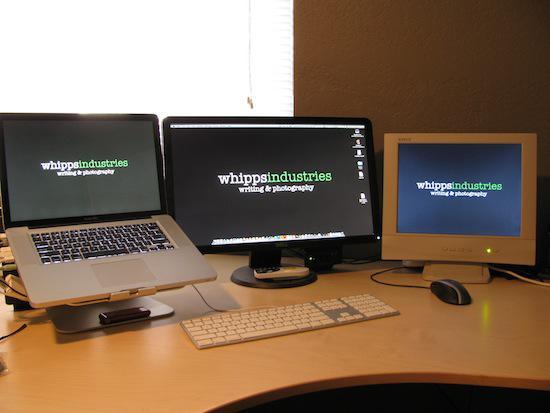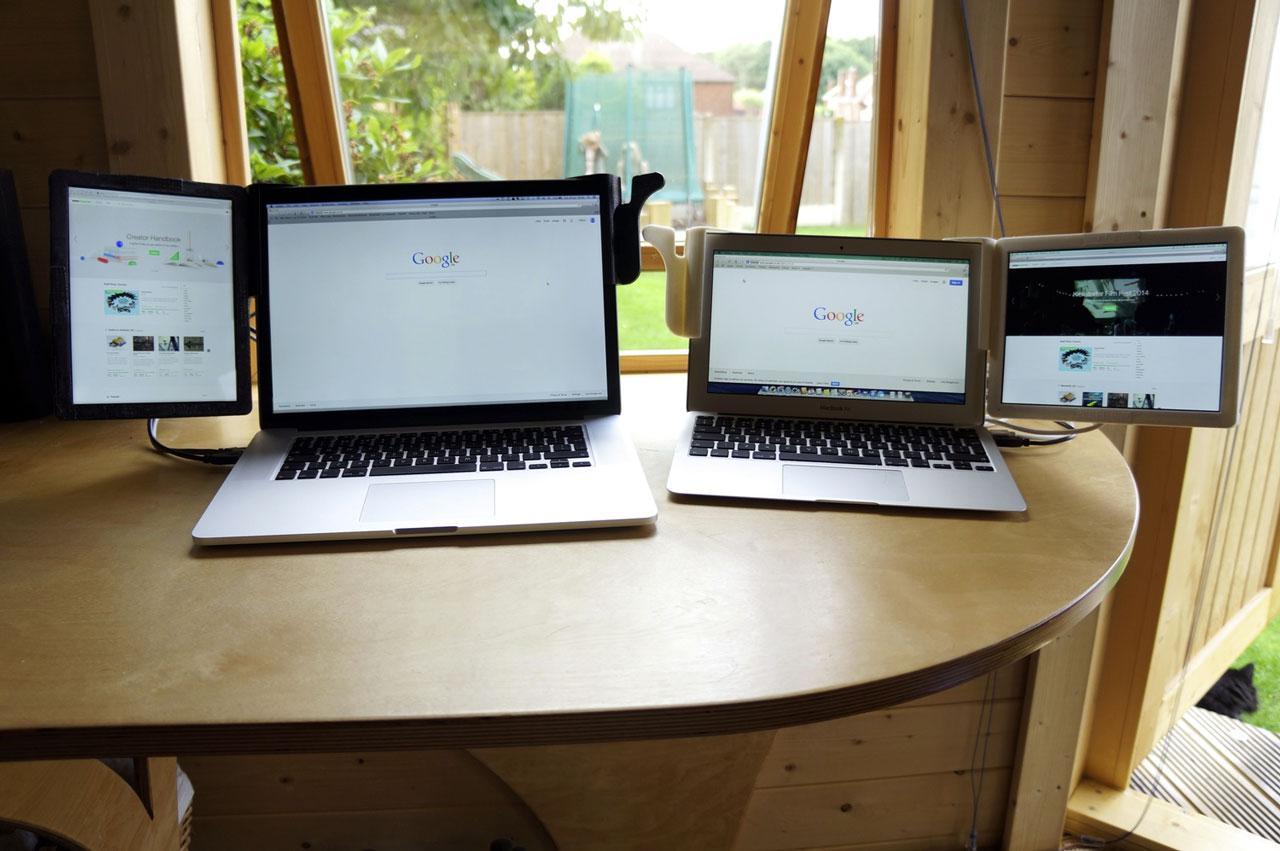The first image is the image on the left, the second image is the image on the right. Evaluate the accuracy of this statement regarding the images: "Both of the tables under the computers have straight edges.". Is it true? Answer yes or no. No. The first image is the image on the left, the second image is the image on the right. For the images shown, is this caption "The left image shows exactly two open screen devices, one distinctly smaller than the other and positioned next to it on a table." true? Answer yes or no. No. 